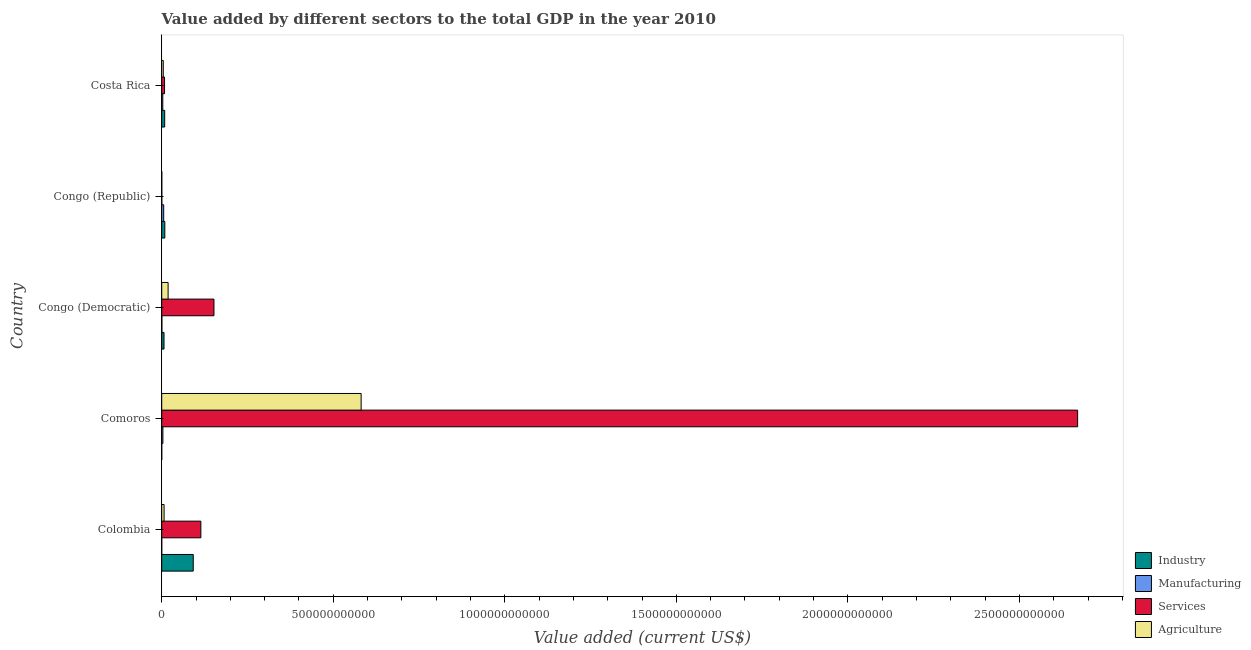How many groups of bars are there?
Offer a very short reply. 5. How many bars are there on the 1st tick from the top?
Your answer should be compact. 4. How many bars are there on the 5th tick from the bottom?
Your answer should be very brief. 4. What is the label of the 2nd group of bars from the top?
Your answer should be compact. Congo (Republic). In how many cases, is the number of bars for a given country not equal to the number of legend labels?
Your answer should be compact. 0. What is the value added by services sector in Comoros?
Provide a short and direct response. 2.67e+12. Across all countries, what is the maximum value added by services sector?
Provide a short and direct response. 2.67e+12. Across all countries, what is the minimum value added by services sector?
Offer a very short reply. 2.44e+08. In which country was the value added by agricultural sector maximum?
Give a very brief answer. Comoros. In which country was the value added by agricultural sector minimum?
Offer a terse response. Congo (Republic). What is the total value added by industrial sector in the graph?
Offer a very short reply. 1.16e+11. What is the difference between the value added by manufacturing sector in Congo (Democratic) and that in Congo (Republic)?
Provide a succinct answer. -5.36e+09. What is the difference between the value added by services sector in Congo (Democratic) and the value added by agricultural sector in Comoros?
Make the answer very short. -4.29e+11. What is the average value added by industrial sector per country?
Your response must be concise. 2.33e+1. What is the difference between the value added by agricultural sector and value added by industrial sector in Congo (Republic)?
Give a very brief answer. -8.84e+09. What is the ratio of the value added by industrial sector in Congo (Democratic) to that in Costa Rica?
Ensure brevity in your answer.  0.78. What is the difference between the highest and the second highest value added by industrial sector?
Your response must be concise. 8.29e+1. What is the difference between the highest and the lowest value added by services sector?
Ensure brevity in your answer.  2.67e+12. In how many countries, is the value added by manufacturing sector greater than the average value added by manufacturing sector taken over all countries?
Give a very brief answer. 3. What does the 3rd bar from the top in Costa Rica represents?
Offer a very short reply. Manufacturing. What does the 4th bar from the bottom in Congo (Republic) represents?
Your answer should be very brief. Agriculture. Are all the bars in the graph horizontal?
Your answer should be compact. Yes. What is the difference between two consecutive major ticks on the X-axis?
Make the answer very short. 5.00e+11. Does the graph contain any zero values?
Provide a succinct answer. No. What is the title of the graph?
Make the answer very short. Value added by different sectors to the total GDP in the year 2010. What is the label or title of the X-axis?
Ensure brevity in your answer.  Value added (current US$). What is the Value added (current US$) in Industry in Colombia?
Offer a very short reply. 9.19e+1. What is the Value added (current US$) of Manufacturing in Colombia?
Keep it short and to the point. 2.77e+07. What is the Value added (current US$) of Services in Colombia?
Keep it short and to the point. 1.14e+11. What is the Value added (current US$) in Agriculture in Colombia?
Give a very brief answer. 6.94e+09. What is the Value added (current US$) in Industry in Comoros?
Give a very brief answer. 6.26e+07. What is the Value added (current US$) in Manufacturing in Comoros?
Your answer should be compact. 3.50e+09. What is the Value added (current US$) of Services in Comoros?
Keep it short and to the point. 2.67e+12. What is the Value added (current US$) of Agriculture in Comoros?
Your answer should be compact. 5.81e+11. What is the Value added (current US$) in Industry in Congo (Democratic)?
Ensure brevity in your answer.  6.74e+09. What is the Value added (current US$) in Manufacturing in Congo (Democratic)?
Offer a terse response. 4.54e+08. What is the Value added (current US$) of Services in Congo (Democratic)?
Your answer should be compact. 1.52e+11. What is the Value added (current US$) of Agriculture in Congo (Democratic)?
Offer a terse response. 1.87e+1. What is the Value added (current US$) of Industry in Congo (Republic)?
Your response must be concise. 9.05e+09. What is the Value added (current US$) of Manufacturing in Congo (Republic)?
Your response must be concise. 5.81e+09. What is the Value added (current US$) of Services in Congo (Republic)?
Provide a short and direct response. 2.44e+08. What is the Value added (current US$) in Agriculture in Congo (Republic)?
Provide a succinct answer. 2.10e+08. What is the Value added (current US$) of Industry in Costa Rica?
Your response must be concise. 8.66e+09. What is the Value added (current US$) of Manufacturing in Costa Rica?
Give a very brief answer. 3.14e+09. What is the Value added (current US$) of Services in Costa Rica?
Ensure brevity in your answer.  8.29e+09. What is the Value added (current US$) of Agriculture in Costa Rica?
Give a very brief answer. 4.57e+09. Across all countries, what is the maximum Value added (current US$) of Industry?
Your response must be concise. 9.19e+1. Across all countries, what is the maximum Value added (current US$) of Manufacturing?
Provide a succinct answer. 5.81e+09. Across all countries, what is the maximum Value added (current US$) of Services?
Offer a very short reply. 2.67e+12. Across all countries, what is the maximum Value added (current US$) of Agriculture?
Ensure brevity in your answer.  5.81e+11. Across all countries, what is the minimum Value added (current US$) in Industry?
Your answer should be very brief. 6.26e+07. Across all countries, what is the minimum Value added (current US$) of Manufacturing?
Ensure brevity in your answer.  2.77e+07. Across all countries, what is the minimum Value added (current US$) of Services?
Offer a very short reply. 2.44e+08. Across all countries, what is the minimum Value added (current US$) in Agriculture?
Your answer should be very brief. 2.10e+08. What is the total Value added (current US$) of Industry in the graph?
Ensure brevity in your answer.  1.16e+11. What is the total Value added (current US$) in Manufacturing in the graph?
Make the answer very short. 1.29e+1. What is the total Value added (current US$) of Services in the graph?
Ensure brevity in your answer.  2.94e+12. What is the total Value added (current US$) in Agriculture in the graph?
Offer a terse response. 6.12e+11. What is the difference between the Value added (current US$) in Industry in Colombia and that in Comoros?
Ensure brevity in your answer.  9.18e+1. What is the difference between the Value added (current US$) of Manufacturing in Colombia and that in Comoros?
Ensure brevity in your answer.  -3.47e+09. What is the difference between the Value added (current US$) in Services in Colombia and that in Comoros?
Ensure brevity in your answer.  -2.56e+12. What is the difference between the Value added (current US$) of Agriculture in Colombia and that in Comoros?
Provide a short and direct response. -5.74e+11. What is the difference between the Value added (current US$) in Industry in Colombia and that in Congo (Democratic)?
Provide a succinct answer. 8.52e+1. What is the difference between the Value added (current US$) in Manufacturing in Colombia and that in Congo (Democratic)?
Offer a very short reply. -4.27e+08. What is the difference between the Value added (current US$) of Services in Colombia and that in Congo (Democratic)?
Your answer should be compact. -3.82e+1. What is the difference between the Value added (current US$) of Agriculture in Colombia and that in Congo (Democratic)?
Make the answer very short. -1.17e+1. What is the difference between the Value added (current US$) in Industry in Colombia and that in Congo (Republic)?
Make the answer very short. 8.29e+1. What is the difference between the Value added (current US$) of Manufacturing in Colombia and that in Congo (Republic)?
Your answer should be very brief. -5.78e+09. What is the difference between the Value added (current US$) of Services in Colombia and that in Congo (Republic)?
Provide a succinct answer. 1.14e+11. What is the difference between the Value added (current US$) of Agriculture in Colombia and that in Congo (Republic)?
Your answer should be very brief. 6.73e+09. What is the difference between the Value added (current US$) in Industry in Colombia and that in Costa Rica?
Keep it short and to the point. 8.32e+1. What is the difference between the Value added (current US$) in Manufacturing in Colombia and that in Costa Rica?
Your answer should be compact. -3.11e+09. What is the difference between the Value added (current US$) in Services in Colombia and that in Costa Rica?
Your answer should be very brief. 1.06e+11. What is the difference between the Value added (current US$) in Agriculture in Colombia and that in Costa Rica?
Your answer should be very brief. 2.36e+09. What is the difference between the Value added (current US$) in Industry in Comoros and that in Congo (Democratic)?
Offer a very short reply. -6.67e+09. What is the difference between the Value added (current US$) in Manufacturing in Comoros and that in Congo (Democratic)?
Offer a very short reply. 3.04e+09. What is the difference between the Value added (current US$) in Services in Comoros and that in Congo (Democratic)?
Ensure brevity in your answer.  2.52e+12. What is the difference between the Value added (current US$) in Agriculture in Comoros and that in Congo (Democratic)?
Ensure brevity in your answer.  5.63e+11. What is the difference between the Value added (current US$) of Industry in Comoros and that in Congo (Republic)?
Offer a terse response. -8.99e+09. What is the difference between the Value added (current US$) in Manufacturing in Comoros and that in Congo (Republic)?
Give a very brief answer. -2.31e+09. What is the difference between the Value added (current US$) of Services in Comoros and that in Congo (Republic)?
Keep it short and to the point. 2.67e+12. What is the difference between the Value added (current US$) of Agriculture in Comoros and that in Congo (Republic)?
Offer a very short reply. 5.81e+11. What is the difference between the Value added (current US$) of Industry in Comoros and that in Costa Rica?
Offer a terse response. -8.60e+09. What is the difference between the Value added (current US$) in Manufacturing in Comoros and that in Costa Rica?
Provide a succinct answer. 3.56e+08. What is the difference between the Value added (current US$) in Services in Comoros and that in Costa Rica?
Your answer should be compact. 2.66e+12. What is the difference between the Value added (current US$) in Agriculture in Comoros and that in Costa Rica?
Offer a very short reply. 5.77e+11. What is the difference between the Value added (current US$) of Industry in Congo (Democratic) and that in Congo (Republic)?
Provide a succinct answer. -2.31e+09. What is the difference between the Value added (current US$) of Manufacturing in Congo (Democratic) and that in Congo (Republic)?
Offer a terse response. -5.36e+09. What is the difference between the Value added (current US$) in Services in Congo (Democratic) and that in Congo (Republic)?
Offer a terse response. 1.52e+11. What is the difference between the Value added (current US$) in Agriculture in Congo (Democratic) and that in Congo (Republic)?
Make the answer very short. 1.85e+1. What is the difference between the Value added (current US$) in Industry in Congo (Democratic) and that in Costa Rica?
Provide a succinct answer. -1.93e+09. What is the difference between the Value added (current US$) of Manufacturing in Congo (Democratic) and that in Costa Rica?
Keep it short and to the point. -2.69e+09. What is the difference between the Value added (current US$) of Services in Congo (Democratic) and that in Costa Rica?
Give a very brief answer. 1.44e+11. What is the difference between the Value added (current US$) in Agriculture in Congo (Democratic) and that in Costa Rica?
Provide a succinct answer. 1.41e+1. What is the difference between the Value added (current US$) in Industry in Congo (Republic) and that in Costa Rica?
Offer a terse response. 3.89e+08. What is the difference between the Value added (current US$) in Manufacturing in Congo (Republic) and that in Costa Rica?
Offer a very short reply. 2.67e+09. What is the difference between the Value added (current US$) of Services in Congo (Republic) and that in Costa Rica?
Your answer should be very brief. -8.04e+09. What is the difference between the Value added (current US$) of Agriculture in Congo (Republic) and that in Costa Rica?
Give a very brief answer. -4.36e+09. What is the difference between the Value added (current US$) of Industry in Colombia and the Value added (current US$) of Manufacturing in Comoros?
Keep it short and to the point. 8.84e+1. What is the difference between the Value added (current US$) of Industry in Colombia and the Value added (current US$) of Services in Comoros?
Provide a succinct answer. -2.58e+12. What is the difference between the Value added (current US$) of Industry in Colombia and the Value added (current US$) of Agriculture in Comoros?
Give a very brief answer. -4.89e+11. What is the difference between the Value added (current US$) in Manufacturing in Colombia and the Value added (current US$) in Services in Comoros?
Offer a very short reply. -2.67e+12. What is the difference between the Value added (current US$) in Manufacturing in Colombia and the Value added (current US$) in Agriculture in Comoros?
Give a very brief answer. -5.81e+11. What is the difference between the Value added (current US$) in Services in Colombia and the Value added (current US$) in Agriculture in Comoros?
Provide a succinct answer. -4.67e+11. What is the difference between the Value added (current US$) in Industry in Colombia and the Value added (current US$) in Manufacturing in Congo (Democratic)?
Give a very brief answer. 9.14e+1. What is the difference between the Value added (current US$) in Industry in Colombia and the Value added (current US$) in Services in Congo (Democratic)?
Make the answer very short. -6.04e+1. What is the difference between the Value added (current US$) in Industry in Colombia and the Value added (current US$) in Agriculture in Congo (Democratic)?
Provide a short and direct response. 7.32e+1. What is the difference between the Value added (current US$) in Manufacturing in Colombia and the Value added (current US$) in Services in Congo (Democratic)?
Make the answer very short. -1.52e+11. What is the difference between the Value added (current US$) of Manufacturing in Colombia and the Value added (current US$) of Agriculture in Congo (Democratic)?
Your answer should be very brief. -1.86e+1. What is the difference between the Value added (current US$) of Services in Colombia and the Value added (current US$) of Agriculture in Congo (Democratic)?
Keep it short and to the point. 9.54e+1. What is the difference between the Value added (current US$) in Industry in Colombia and the Value added (current US$) in Manufacturing in Congo (Republic)?
Offer a terse response. 8.61e+1. What is the difference between the Value added (current US$) of Industry in Colombia and the Value added (current US$) of Services in Congo (Republic)?
Ensure brevity in your answer.  9.17e+1. What is the difference between the Value added (current US$) in Industry in Colombia and the Value added (current US$) in Agriculture in Congo (Republic)?
Ensure brevity in your answer.  9.17e+1. What is the difference between the Value added (current US$) in Manufacturing in Colombia and the Value added (current US$) in Services in Congo (Republic)?
Your answer should be compact. -2.17e+08. What is the difference between the Value added (current US$) of Manufacturing in Colombia and the Value added (current US$) of Agriculture in Congo (Republic)?
Provide a succinct answer. -1.82e+08. What is the difference between the Value added (current US$) of Services in Colombia and the Value added (current US$) of Agriculture in Congo (Republic)?
Offer a terse response. 1.14e+11. What is the difference between the Value added (current US$) of Industry in Colombia and the Value added (current US$) of Manufacturing in Costa Rica?
Offer a very short reply. 8.88e+1. What is the difference between the Value added (current US$) of Industry in Colombia and the Value added (current US$) of Services in Costa Rica?
Make the answer very short. 8.36e+1. What is the difference between the Value added (current US$) in Industry in Colombia and the Value added (current US$) in Agriculture in Costa Rica?
Give a very brief answer. 8.73e+1. What is the difference between the Value added (current US$) in Manufacturing in Colombia and the Value added (current US$) in Services in Costa Rica?
Your response must be concise. -8.26e+09. What is the difference between the Value added (current US$) of Manufacturing in Colombia and the Value added (current US$) of Agriculture in Costa Rica?
Give a very brief answer. -4.55e+09. What is the difference between the Value added (current US$) in Services in Colombia and the Value added (current US$) in Agriculture in Costa Rica?
Keep it short and to the point. 1.10e+11. What is the difference between the Value added (current US$) of Industry in Comoros and the Value added (current US$) of Manufacturing in Congo (Democratic)?
Offer a terse response. -3.92e+08. What is the difference between the Value added (current US$) of Industry in Comoros and the Value added (current US$) of Services in Congo (Democratic)?
Provide a short and direct response. -1.52e+11. What is the difference between the Value added (current US$) of Industry in Comoros and the Value added (current US$) of Agriculture in Congo (Democratic)?
Your response must be concise. -1.86e+1. What is the difference between the Value added (current US$) in Manufacturing in Comoros and the Value added (current US$) in Services in Congo (Democratic)?
Your answer should be compact. -1.49e+11. What is the difference between the Value added (current US$) in Manufacturing in Comoros and the Value added (current US$) in Agriculture in Congo (Democratic)?
Ensure brevity in your answer.  -1.52e+1. What is the difference between the Value added (current US$) in Services in Comoros and the Value added (current US$) in Agriculture in Congo (Democratic)?
Offer a terse response. 2.65e+12. What is the difference between the Value added (current US$) of Industry in Comoros and the Value added (current US$) of Manufacturing in Congo (Republic)?
Ensure brevity in your answer.  -5.75e+09. What is the difference between the Value added (current US$) of Industry in Comoros and the Value added (current US$) of Services in Congo (Republic)?
Provide a short and direct response. -1.82e+08. What is the difference between the Value added (current US$) in Industry in Comoros and the Value added (current US$) in Agriculture in Congo (Republic)?
Your answer should be very brief. -1.47e+08. What is the difference between the Value added (current US$) in Manufacturing in Comoros and the Value added (current US$) in Services in Congo (Republic)?
Your answer should be very brief. 3.25e+09. What is the difference between the Value added (current US$) of Manufacturing in Comoros and the Value added (current US$) of Agriculture in Congo (Republic)?
Make the answer very short. 3.29e+09. What is the difference between the Value added (current US$) of Services in Comoros and the Value added (current US$) of Agriculture in Congo (Republic)?
Keep it short and to the point. 2.67e+12. What is the difference between the Value added (current US$) in Industry in Comoros and the Value added (current US$) in Manufacturing in Costa Rica?
Give a very brief answer. -3.08e+09. What is the difference between the Value added (current US$) in Industry in Comoros and the Value added (current US$) in Services in Costa Rica?
Your answer should be very brief. -8.22e+09. What is the difference between the Value added (current US$) in Industry in Comoros and the Value added (current US$) in Agriculture in Costa Rica?
Make the answer very short. -4.51e+09. What is the difference between the Value added (current US$) of Manufacturing in Comoros and the Value added (current US$) of Services in Costa Rica?
Provide a succinct answer. -4.79e+09. What is the difference between the Value added (current US$) in Manufacturing in Comoros and the Value added (current US$) in Agriculture in Costa Rica?
Keep it short and to the point. -1.07e+09. What is the difference between the Value added (current US$) of Services in Comoros and the Value added (current US$) of Agriculture in Costa Rica?
Ensure brevity in your answer.  2.67e+12. What is the difference between the Value added (current US$) of Industry in Congo (Democratic) and the Value added (current US$) of Manufacturing in Congo (Republic)?
Your response must be concise. 9.26e+08. What is the difference between the Value added (current US$) in Industry in Congo (Democratic) and the Value added (current US$) in Services in Congo (Republic)?
Your answer should be compact. 6.49e+09. What is the difference between the Value added (current US$) in Industry in Congo (Democratic) and the Value added (current US$) in Agriculture in Congo (Republic)?
Ensure brevity in your answer.  6.53e+09. What is the difference between the Value added (current US$) of Manufacturing in Congo (Democratic) and the Value added (current US$) of Services in Congo (Republic)?
Provide a succinct answer. 2.10e+08. What is the difference between the Value added (current US$) in Manufacturing in Congo (Democratic) and the Value added (current US$) in Agriculture in Congo (Republic)?
Provide a short and direct response. 2.44e+08. What is the difference between the Value added (current US$) in Services in Congo (Democratic) and the Value added (current US$) in Agriculture in Congo (Republic)?
Ensure brevity in your answer.  1.52e+11. What is the difference between the Value added (current US$) in Industry in Congo (Democratic) and the Value added (current US$) in Manufacturing in Costa Rica?
Make the answer very short. 3.60e+09. What is the difference between the Value added (current US$) of Industry in Congo (Democratic) and the Value added (current US$) of Services in Costa Rica?
Offer a terse response. -1.55e+09. What is the difference between the Value added (current US$) in Industry in Congo (Democratic) and the Value added (current US$) in Agriculture in Costa Rica?
Your response must be concise. 2.16e+09. What is the difference between the Value added (current US$) in Manufacturing in Congo (Democratic) and the Value added (current US$) in Services in Costa Rica?
Ensure brevity in your answer.  -7.83e+09. What is the difference between the Value added (current US$) in Manufacturing in Congo (Democratic) and the Value added (current US$) in Agriculture in Costa Rica?
Your response must be concise. -4.12e+09. What is the difference between the Value added (current US$) of Services in Congo (Democratic) and the Value added (current US$) of Agriculture in Costa Rica?
Your response must be concise. 1.48e+11. What is the difference between the Value added (current US$) in Industry in Congo (Republic) and the Value added (current US$) in Manufacturing in Costa Rica?
Give a very brief answer. 5.91e+09. What is the difference between the Value added (current US$) of Industry in Congo (Republic) and the Value added (current US$) of Services in Costa Rica?
Your answer should be compact. 7.66e+08. What is the difference between the Value added (current US$) in Industry in Congo (Republic) and the Value added (current US$) in Agriculture in Costa Rica?
Your answer should be very brief. 4.48e+09. What is the difference between the Value added (current US$) in Manufacturing in Congo (Republic) and the Value added (current US$) in Services in Costa Rica?
Your answer should be very brief. -2.47e+09. What is the difference between the Value added (current US$) of Manufacturing in Congo (Republic) and the Value added (current US$) of Agriculture in Costa Rica?
Give a very brief answer. 1.24e+09. What is the difference between the Value added (current US$) of Services in Congo (Republic) and the Value added (current US$) of Agriculture in Costa Rica?
Keep it short and to the point. -4.33e+09. What is the average Value added (current US$) of Industry per country?
Offer a terse response. 2.33e+1. What is the average Value added (current US$) in Manufacturing per country?
Provide a succinct answer. 2.59e+09. What is the average Value added (current US$) of Services per country?
Give a very brief answer. 5.89e+11. What is the average Value added (current US$) in Agriculture per country?
Offer a terse response. 1.22e+11. What is the difference between the Value added (current US$) in Industry and Value added (current US$) in Manufacturing in Colombia?
Offer a very short reply. 9.19e+1. What is the difference between the Value added (current US$) of Industry and Value added (current US$) of Services in Colombia?
Your answer should be very brief. -2.22e+1. What is the difference between the Value added (current US$) of Industry and Value added (current US$) of Agriculture in Colombia?
Keep it short and to the point. 8.50e+1. What is the difference between the Value added (current US$) of Manufacturing and Value added (current US$) of Services in Colombia?
Offer a very short reply. -1.14e+11. What is the difference between the Value added (current US$) of Manufacturing and Value added (current US$) of Agriculture in Colombia?
Provide a short and direct response. -6.91e+09. What is the difference between the Value added (current US$) in Services and Value added (current US$) in Agriculture in Colombia?
Provide a succinct answer. 1.07e+11. What is the difference between the Value added (current US$) of Industry and Value added (current US$) of Manufacturing in Comoros?
Provide a short and direct response. -3.44e+09. What is the difference between the Value added (current US$) of Industry and Value added (current US$) of Services in Comoros?
Keep it short and to the point. -2.67e+12. What is the difference between the Value added (current US$) of Industry and Value added (current US$) of Agriculture in Comoros?
Provide a succinct answer. -5.81e+11. What is the difference between the Value added (current US$) of Manufacturing and Value added (current US$) of Services in Comoros?
Ensure brevity in your answer.  -2.67e+12. What is the difference between the Value added (current US$) of Manufacturing and Value added (current US$) of Agriculture in Comoros?
Make the answer very short. -5.78e+11. What is the difference between the Value added (current US$) in Services and Value added (current US$) in Agriculture in Comoros?
Provide a succinct answer. 2.09e+12. What is the difference between the Value added (current US$) in Industry and Value added (current US$) in Manufacturing in Congo (Democratic)?
Offer a very short reply. 6.28e+09. What is the difference between the Value added (current US$) in Industry and Value added (current US$) in Services in Congo (Democratic)?
Give a very brief answer. -1.46e+11. What is the difference between the Value added (current US$) in Industry and Value added (current US$) in Agriculture in Congo (Democratic)?
Make the answer very short. -1.19e+1. What is the difference between the Value added (current US$) in Manufacturing and Value added (current US$) in Services in Congo (Democratic)?
Your response must be concise. -1.52e+11. What is the difference between the Value added (current US$) in Manufacturing and Value added (current US$) in Agriculture in Congo (Democratic)?
Keep it short and to the point. -1.82e+1. What is the difference between the Value added (current US$) of Services and Value added (current US$) of Agriculture in Congo (Democratic)?
Provide a succinct answer. 1.34e+11. What is the difference between the Value added (current US$) of Industry and Value added (current US$) of Manufacturing in Congo (Republic)?
Provide a succinct answer. 3.24e+09. What is the difference between the Value added (current US$) in Industry and Value added (current US$) in Services in Congo (Republic)?
Your response must be concise. 8.81e+09. What is the difference between the Value added (current US$) in Industry and Value added (current US$) in Agriculture in Congo (Republic)?
Offer a terse response. 8.84e+09. What is the difference between the Value added (current US$) of Manufacturing and Value added (current US$) of Services in Congo (Republic)?
Your answer should be compact. 5.57e+09. What is the difference between the Value added (current US$) of Manufacturing and Value added (current US$) of Agriculture in Congo (Republic)?
Offer a very short reply. 5.60e+09. What is the difference between the Value added (current US$) of Services and Value added (current US$) of Agriculture in Congo (Republic)?
Give a very brief answer. 3.45e+07. What is the difference between the Value added (current US$) of Industry and Value added (current US$) of Manufacturing in Costa Rica?
Keep it short and to the point. 5.52e+09. What is the difference between the Value added (current US$) of Industry and Value added (current US$) of Services in Costa Rica?
Your answer should be compact. 3.77e+08. What is the difference between the Value added (current US$) in Industry and Value added (current US$) in Agriculture in Costa Rica?
Provide a short and direct response. 4.09e+09. What is the difference between the Value added (current US$) of Manufacturing and Value added (current US$) of Services in Costa Rica?
Keep it short and to the point. -5.14e+09. What is the difference between the Value added (current US$) of Manufacturing and Value added (current US$) of Agriculture in Costa Rica?
Give a very brief answer. -1.43e+09. What is the difference between the Value added (current US$) in Services and Value added (current US$) in Agriculture in Costa Rica?
Keep it short and to the point. 3.71e+09. What is the ratio of the Value added (current US$) of Industry in Colombia to that in Comoros?
Offer a very short reply. 1469.26. What is the ratio of the Value added (current US$) in Manufacturing in Colombia to that in Comoros?
Give a very brief answer. 0.01. What is the ratio of the Value added (current US$) in Services in Colombia to that in Comoros?
Ensure brevity in your answer.  0.04. What is the ratio of the Value added (current US$) of Agriculture in Colombia to that in Comoros?
Offer a very short reply. 0.01. What is the ratio of the Value added (current US$) of Industry in Colombia to that in Congo (Democratic)?
Offer a very short reply. 13.64. What is the ratio of the Value added (current US$) in Manufacturing in Colombia to that in Congo (Democratic)?
Your answer should be compact. 0.06. What is the ratio of the Value added (current US$) of Services in Colombia to that in Congo (Democratic)?
Offer a very short reply. 0.75. What is the ratio of the Value added (current US$) in Agriculture in Colombia to that in Congo (Democratic)?
Your answer should be very brief. 0.37. What is the ratio of the Value added (current US$) in Industry in Colombia to that in Congo (Republic)?
Provide a short and direct response. 10.15. What is the ratio of the Value added (current US$) of Manufacturing in Colombia to that in Congo (Republic)?
Ensure brevity in your answer.  0. What is the ratio of the Value added (current US$) in Services in Colombia to that in Congo (Republic)?
Ensure brevity in your answer.  466.69. What is the ratio of the Value added (current US$) of Agriculture in Colombia to that in Congo (Republic)?
Provide a succinct answer. 33.04. What is the ratio of the Value added (current US$) of Industry in Colombia to that in Costa Rica?
Provide a short and direct response. 10.61. What is the ratio of the Value added (current US$) in Manufacturing in Colombia to that in Costa Rica?
Give a very brief answer. 0.01. What is the ratio of the Value added (current US$) in Services in Colombia to that in Costa Rica?
Ensure brevity in your answer.  13.77. What is the ratio of the Value added (current US$) of Agriculture in Colombia to that in Costa Rica?
Ensure brevity in your answer.  1.52. What is the ratio of the Value added (current US$) of Industry in Comoros to that in Congo (Democratic)?
Offer a very short reply. 0.01. What is the ratio of the Value added (current US$) in Manufacturing in Comoros to that in Congo (Democratic)?
Make the answer very short. 7.7. What is the ratio of the Value added (current US$) of Services in Comoros to that in Congo (Democratic)?
Your answer should be compact. 17.52. What is the ratio of the Value added (current US$) in Agriculture in Comoros to that in Congo (Democratic)?
Ensure brevity in your answer.  31.15. What is the ratio of the Value added (current US$) in Industry in Comoros to that in Congo (Republic)?
Give a very brief answer. 0.01. What is the ratio of the Value added (current US$) in Manufacturing in Comoros to that in Congo (Republic)?
Give a very brief answer. 0.6. What is the ratio of the Value added (current US$) of Services in Comoros to that in Congo (Republic)?
Your answer should be very brief. 1.09e+04. What is the ratio of the Value added (current US$) in Agriculture in Comoros to that in Congo (Republic)?
Give a very brief answer. 2768.84. What is the ratio of the Value added (current US$) of Industry in Comoros to that in Costa Rica?
Your answer should be compact. 0.01. What is the ratio of the Value added (current US$) in Manufacturing in Comoros to that in Costa Rica?
Your response must be concise. 1.11. What is the ratio of the Value added (current US$) in Services in Comoros to that in Costa Rica?
Keep it short and to the point. 322.21. What is the ratio of the Value added (current US$) in Agriculture in Comoros to that in Costa Rica?
Make the answer very short. 127.11. What is the ratio of the Value added (current US$) of Industry in Congo (Democratic) to that in Congo (Republic)?
Your response must be concise. 0.74. What is the ratio of the Value added (current US$) in Manufacturing in Congo (Democratic) to that in Congo (Republic)?
Give a very brief answer. 0.08. What is the ratio of the Value added (current US$) in Services in Congo (Democratic) to that in Congo (Republic)?
Offer a very short reply. 623.11. What is the ratio of the Value added (current US$) of Agriculture in Congo (Democratic) to that in Congo (Republic)?
Make the answer very short. 88.89. What is the ratio of the Value added (current US$) in Industry in Congo (Democratic) to that in Costa Rica?
Keep it short and to the point. 0.78. What is the ratio of the Value added (current US$) in Manufacturing in Congo (Democratic) to that in Costa Rica?
Offer a terse response. 0.14. What is the ratio of the Value added (current US$) of Services in Congo (Democratic) to that in Costa Rica?
Offer a terse response. 18.39. What is the ratio of the Value added (current US$) in Agriculture in Congo (Democratic) to that in Costa Rica?
Offer a very short reply. 4.08. What is the ratio of the Value added (current US$) in Industry in Congo (Republic) to that in Costa Rica?
Provide a succinct answer. 1.04. What is the ratio of the Value added (current US$) in Manufacturing in Congo (Republic) to that in Costa Rica?
Your answer should be compact. 1.85. What is the ratio of the Value added (current US$) of Services in Congo (Republic) to that in Costa Rica?
Make the answer very short. 0.03. What is the ratio of the Value added (current US$) in Agriculture in Congo (Republic) to that in Costa Rica?
Your response must be concise. 0.05. What is the difference between the highest and the second highest Value added (current US$) of Industry?
Your answer should be very brief. 8.29e+1. What is the difference between the highest and the second highest Value added (current US$) of Manufacturing?
Offer a very short reply. 2.31e+09. What is the difference between the highest and the second highest Value added (current US$) of Services?
Give a very brief answer. 2.52e+12. What is the difference between the highest and the second highest Value added (current US$) of Agriculture?
Your response must be concise. 5.63e+11. What is the difference between the highest and the lowest Value added (current US$) in Industry?
Your answer should be very brief. 9.18e+1. What is the difference between the highest and the lowest Value added (current US$) of Manufacturing?
Make the answer very short. 5.78e+09. What is the difference between the highest and the lowest Value added (current US$) in Services?
Your response must be concise. 2.67e+12. What is the difference between the highest and the lowest Value added (current US$) of Agriculture?
Your answer should be compact. 5.81e+11. 